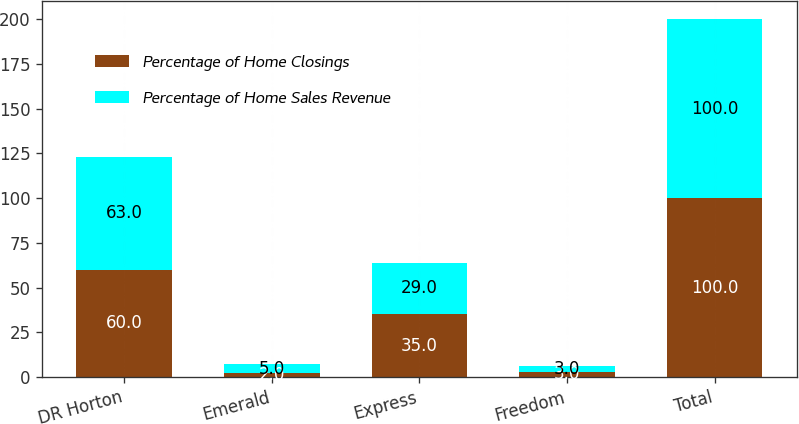Convert chart to OTSL. <chart><loc_0><loc_0><loc_500><loc_500><stacked_bar_chart><ecel><fcel>DR Horton<fcel>Emerald<fcel>Express<fcel>Freedom<fcel>Total<nl><fcel>Percentage of Home Closings<fcel>60<fcel>2<fcel>35<fcel>3<fcel>100<nl><fcel>Percentage of Home Sales Revenue<fcel>63<fcel>5<fcel>29<fcel>3<fcel>100<nl></chart> 